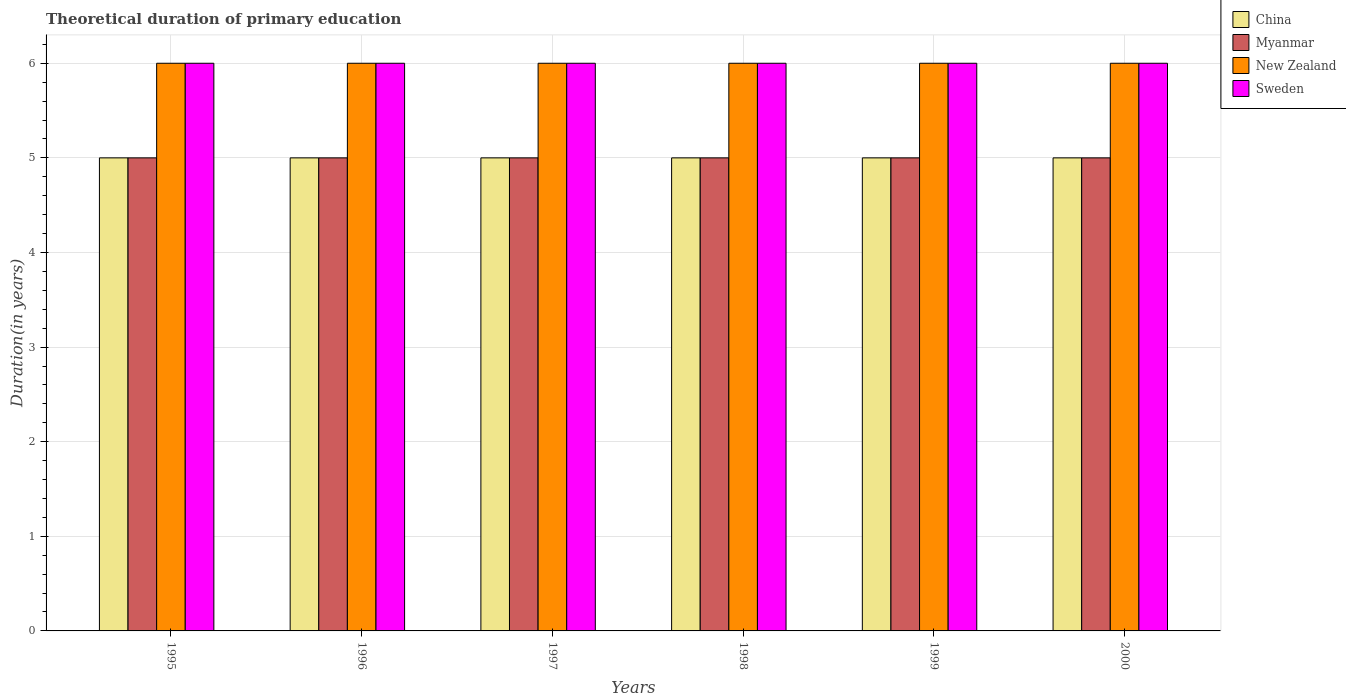How many groups of bars are there?
Ensure brevity in your answer.  6. How many bars are there on the 3rd tick from the left?
Your answer should be very brief. 4. What is the label of the 2nd group of bars from the left?
Your answer should be compact. 1996. What is the total theoretical duration of primary education in New Zealand in 2000?
Provide a short and direct response. 6. Across all years, what is the maximum total theoretical duration of primary education in China?
Provide a succinct answer. 5. Across all years, what is the minimum total theoretical duration of primary education in China?
Give a very brief answer. 5. What is the total total theoretical duration of primary education in China in the graph?
Your response must be concise. 30. What is the difference between the total theoretical duration of primary education in Sweden in 1998 and the total theoretical duration of primary education in China in 1996?
Ensure brevity in your answer.  1. Is the difference between the total theoretical duration of primary education in China in 1997 and 1998 greater than the difference between the total theoretical duration of primary education in Myanmar in 1997 and 1998?
Ensure brevity in your answer.  No. Is the sum of the total theoretical duration of primary education in China in 1995 and 2000 greater than the maximum total theoretical duration of primary education in New Zealand across all years?
Give a very brief answer. Yes. What does the 1st bar from the left in 1998 represents?
Keep it short and to the point. China. What does the 2nd bar from the right in 1999 represents?
Ensure brevity in your answer.  New Zealand. Is it the case that in every year, the sum of the total theoretical duration of primary education in Myanmar and total theoretical duration of primary education in Sweden is greater than the total theoretical duration of primary education in New Zealand?
Ensure brevity in your answer.  Yes. Are all the bars in the graph horizontal?
Make the answer very short. No. Does the graph contain any zero values?
Ensure brevity in your answer.  No. Where does the legend appear in the graph?
Provide a succinct answer. Top right. How are the legend labels stacked?
Your response must be concise. Vertical. What is the title of the graph?
Offer a terse response. Theoretical duration of primary education. What is the label or title of the X-axis?
Offer a very short reply. Years. What is the label or title of the Y-axis?
Make the answer very short. Duration(in years). What is the Duration(in years) in Myanmar in 1995?
Your answer should be very brief. 5. What is the Duration(in years) of New Zealand in 1995?
Provide a succinct answer. 6. What is the Duration(in years) of Sweden in 1995?
Provide a short and direct response. 6. What is the Duration(in years) of Myanmar in 1996?
Keep it short and to the point. 5. What is the Duration(in years) in New Zealand in 1996?
Make the answer very short. 6. What is the Duration(in years) in Sweden in 1996?
Ensure brevity in your answer.  6. What is the Duration(in years) in China in 1997?
Offer a very short reply. 5. What is the Duration(in years) of Myanmar in 1997?
Offer a very short reply. 5. What is the Duration(in years) in Sweden in 1997?
Your answer should be compact. 6. What is the Duration(in years) of China in 1998?
Your answer should be compact. 5. What is the Duration(in years) of New Zealand in 1998?
Your response must be concise. 6. What is the Duration(in years) of Sweden in 1998?
Ensure brevity in your answer.  6. What is the Duration(in years) of China in 1999?
Your answer should be compact. 5. What is the Duration(in years) of New Zealand in 1999?
Provide a succinct answer. 6. What is the Duration(in years) in China in 2000?
Offer a terse response. 5. What is the Duration(in years) of New Zealand in 2000?
Give a very brief answer. 6. What is the Duration(in years) of Sweden in 2000?
Give a very brief answer. 6. Across all years, what is the maximum Duration(in years) of China?
Ensure brevity in your answer.  5. Across all years, what is the maximum Duration(in years) in Myanmar?
Make the answer very short. 5. Across all years, what is the minimum Duration(in years) of China?
Offer a terse response. 5. Across all years, what is the minimum Duration(in years) of Myanmar?
Your answer should be compact. 5. Across all years, what is the minimum Duration(in years) in New Zealand?
Provide a short and direct response. 6. Across all years, what is the minimum Duration(in years) in Sweden?
Make the answer very short. 6. What is the total Duration(in years) in Myanmar in the graph?
Make the answer very short. 30. What is the total Duration(in years) of New Zealand in the graph?
Offer a terse response. 36. What is the difference between the Duration(in years) of China in 1995 and that in 1997?
Offer a terse response. 0. What is the difference between the Duration(in years) in Myanmar in 1995 and that in 1997?
Ensure brevity in your answer.  0. What is the difference between the Duration(in years) in New Zealand in 1995 and that in 1997?
Offer a terse response. 0. What is the difference between the Duration(in years) of Sweden in 1995 and that in 1997?
Give a very brief answer. 0. What is the difference between the Duration(in years) in Myanmar in 1995 and that in 1998?
Keep it short and to the point. 0. What is the difference between the Duration(in years) in New Zealand in 1995 and that in 1998?
Offer a terse response. 0. What is the difference between the Duration(in years) in New Zealand in 1995 and that in 1999?
Provide a short and direct response. 0. What is the difference between the Duration(in years) in China in 1995 and that in 2000?
Provide a succinct answer. 0. What is the difference between the Duration(in years) of Myanmar in 1996 and that in 1997?
Give a very brief answer. 0. What is the difference between the Duration(in years) of New Zealand in 1996 and that in 1997?
Provide a short and direct response. 0. What is the difference between the Duration(in years) of Myanmar in 1996 and that in 1998?
Provide a succinct answer. 0. What is the difference between the Duration(in years) of New Zealand in 1996 and that in 1998?
Ensure brevity in your answer.  0. What is the difference between the Duration(in years) of Myanmar in 1996 and that in 2000?
Your answer should be compact. 0. What is the difference between the Duration(in years) of New Zealand in 1996 and that in 2000?
Offer a very short reply. 0. What is the difference between the Duration(in years) in New Zealand in 1997 and that in 1998?
Give a very brief answer. 0. What is the difference between the Duration(in years) in New Zealand in 1997 and that in 1999?
Offer a terse response. 0. What is the difference between the Duration(in years) in Myanmar in 1997 and that in 2000?
Your answer should be very brief. 0. What is the difference between the Duration(in years) of New Zealand in 1997 and that in 2000?
Offer a terse response. 0. What is the difference between the Duration(in years) in Sweden in 1997 and that in 2000?
Offer a terse response. 0. What is the difference between the Duration(in years) in China in 1998 and that in 2000?
Provide a succinct answer. 0. What is the difference between the Duration(in years) in New Zealand in 1999 and that in 2000?
Ensure brevity in your answer.  0. What is the difference between the Duration(in years) of China in 1995 and the Duration(in years) of New Zealand in 1996?
Offer a very short reply. -1. What is the difference between the Duration(in years) of New Zealand in 1995 and the Duration(in years) of Sweden in 1996?
Your response must be concise. 0. What is the difference between the Duration(in years) in China in 1995 and the Duration(in years) in New Zealand in 1997?
Your answer should be compact. -1. What is the difference between the Duration(in years) in Myanmar in 1995 and the Duration(in years) in New Zealand in 1997?
Make the answer very short. -1. What is the difference between the Duration(in years) of Myanmar in 1995 and the Duration(in years) of Sweden in 1997?
Provide a succinct answer. -1. What is the difference between the Duration(in years) of New Zealand in 1995 and the Duration(in years) of Sweden in 1997?
Provide a succinct answer. 0. What is the difference between the Duration(in years) of China in 1995 and the Duration(in years) of Myanmar in 1998?
Offer a very short reply. 0. What is the difference between the Duration(in years) in China in 1995 and the Duration(in years) in New Zealand in 1998?
Keep it short and to the point. -1. What is the difference between the Duration(in years) of China in 1995 and the Duration(in years) of Sweden in 1998?
Offer a very short reply. -1. What is the difference between the Duration(in years) in Myanmar in 1995 and the Duration(in years) in Sweden in 1998?
Provide a succinct answer. -1. What is the difference between the Duration(in years) of Myanmar in 1995 and the Duration(in years) of New Zealand in 1999?
Keep it short and to the point. -1. What is the difference between the Duration(in years) of Myanmar in 1995 and the Duration(in years) of Sweden in 1999?
Your response must be concise. -1. What is the difference between the Duration(in years) in New Zealand in 1995 and the Duration(in years) in Sweden in 1999?
Make the answer very short. 0. What is the difference between the Duration(in years) of China in 1996 and the Duration(in years) of Myanmar in 1998?
Your response must be concise. 0. What is the difference between the Duration(in years) of China in 1996 and the Duration(in years) of New Zealand in 1998?
Offer a terse response. -1. What is the difference between the Duration(in years) in Myanmar in 1996 and the Duration(in years) in Sweden in 1998?
Provide a succinct answer. -1. What is the difference between the Duration(in years) in China in 1996 and the Duration(in years) in Myanmar in 1999?
Provide a short and direct response. 0. What is the difference between the Duration(in years) in China in 1996 and the Duration(in years) in New Zealand in 1999?
Your answer should be very brief. -1. What is the difference between the Duration(in years) in Myanmar in 1996 and the Duration(in years) in New Zealand in 1999?
Your answer should be very brief. -1. What is the difference between the Duration(in years) in Myanmar in 1996 and the Duration(in years) in Sweden in 1999?
Your answer should be very brief. -1. What is the difference between the Duration(in years) of New Zealand in 1996 and the Duration(in years) of Sweden in 1999?
Your answer should be compact. 0. What is the difference between the Duration(in years) in Myanmar in 1996 and the Duration(in years) in New Zealand in 2000?
Give a very brief answer. -1. What is the difference between the Duration(in years) of China in 1997 and the Duration(in years) of New Zealand in 1998?
Offer a terse response. -1. What is the difference between the Duration(in years) in New Zealand in 1997 and the Duration(in years) in Sweden in 1998?
Ensure brevity in your answer.  0. What is the difference between the Duration(in years) in China in 1997 and the Duration(in years) in New Zealand in 1999?
Give a very brief answer. -1. What is the difference between the Duration(in years) in China in 1997 and the Duration(in years) in Sweden in 1999?
Ensure brevity in your answer.  -1. What is the difference between the Duration(in years) in Myanmar in 1997 and the Duration(in years) in New Zealand in 1999?
Keep it short and to the point. -1. What is the difference between the Duration(in years) in Myanmar in 1997 and the Duration(in years) in Sweden in 1999?
Make the answer very short. -1. What is the difference between the Duration(in years) in Myanmar in 1997 and the Duration(in years) in New Zealand in 2000?
Ensure brevity in your answer.  -1. What is the difference between the Duration(in years) of Myanmar in 1997 and the Duration(in years) of Sweden in 2000?
Provide a short and direct response. -1. What is the difference between the Duration(in years) of China in 1998 and the Duration(in years) of New Zealand in 1999?
Provide a short and direct response. -1. What is the difference between the Duration(in years) in China in 1998 and the Duration(in years) in Sweden in 1999?
Your answer should be very brief. -1. What is the difference between the Duration(in years) of Myanmar in 1998 and the Duration(in years) of Sweden in 1999?
Make the answer very short. -1. What is the difference between the Duration(in years) in New Zealand in 1998 and the Duration(in years) in Sweden in 1999?
Provide a short and direct response. 0. What is the difference between the Duration(in years) in China in 1998 and the Duration(in years) in New Zealand in 2000?
Ensure brevity in your answer.  -1. What is the difference between the Duration(in years) of China in 1998 and the Duration(in years) of Sweden in 2000?
Make the answer very short. -1. What is the difference between the Duration(in years) of Myanmar in 1998 and the Duration(in years) of New Zealand in 2000?
Give a very brief answer. -1. What is the difference between the Duration(in years) in China in 1999 and the Duration(in years) in Myanmar in 2000?
Provide a succinct answer. 0. What is the difference between the Duration(in years) of China in 1999 and the Duration(in years) of Sweden in 2000?
Your response must be concise. -1. What is the difference between the Duration(in years) of Myanmar in 1999 and the Duration(in years) of New Zealand in 2000?
Give a very brief answer. -1. What is the difference between the Duration(in years) in Myanmar in 1999 and the Duration(in years) in Sweden in 2000?
Ensure brevity in your answer.  -1. What is the average Duration(in years) of New Zealand per year?
Provide a succinct answer. 6. What is the average Duration(in years) in Sweden per year?
Your response must be concise. 6. In the year 1995, what is the difference between the Duration(in years) in China and Duration(in years) in New Zealand?
Provide a succinct answer. -1. In the year 1995, what is the difference between the Duration(in years) of China and Duration(in years) of Sweden?
Provide a succinct answer. -1. In the year 1995, what is the difference between the Duration(in years) in New Zealand and Duration(in years) in Sweden?
Your answer should be compact. 0. In the year 1996, what is the difference between the Duration(in years) of Myanmar and Duration(in years) of Sweden?
Provide a succinct answer. -1. In the year 1996, what is the difference between the Duration(in years) in New Zealand and Duration(in years) in Sweden?
Provide a short and direct response. 0. In the year 1997, what is the difference between the Duration(in years) in China and Duration(in years) in Myanmar?
Offer a very short reply. 0. In the year 1997, what is the difference between the Duration(in years) of New Zealand and Duration(in years) of Sweden?
Your answer should be very brief. 0. In the year 1998, what is the difference between the Duration(in years) in China and Duration(in years) in Myanmar?
Ensure brevity in your answer.  0. In the year 1998, what is the difference between the Duration(in years) in New Zealand and Duration(in years) in Sweden?
Offer a terse response. 0. In the year 1999, what is the difference between the Duration(in years) in China and Duration(in years) in New Zealand?
Give a very brief answer. -1. In the year 1999, what is the difference between the Duration(in years) in China and Duration(in years) in Sweden?
Keep it short and to the point. -1. In the year 1999, what is the difference between the Duration(in years) of Myanmar and Duration(in years) of New Zealand?
Provide a succinct answer. -1. In the year 2000, what is the difference between the Duration(in years) of China and Duration(in years) of Myanmar?
Make the answer very short. 0. In the year 2000, what is the difference between the Duration(in years) in China and Duration(in years) in Sweden?
Make the answer very short. -1. In the year 2000, what is the difference between the Duration(in years) of Myanmar and Duration(in years) of Sweden?
Provide a succinct answer. -1. In the year 2000, what is the difference between the Duration(in years) in New Zealand and Duration(in years) in Sweden?
Ensure brevity in your answer.  0. What is the ratio of the Duration(in years) in Sweden in 1995 to that in 1996?
Provide a succinct answer. 1. What is the ratio of the Duration(in years) in Myanmar in 1995 to that in 1997?
Your answer should be very brief. 1. What is the ratio of the Duration(in years) in New Zealand in 1995 to that in 1997?
Make the answer very short. 1. What is the ratio of the Duration(in years) in Sweden in 1995 to that in 1997?
Ensure brevity in your answer.  1. What is the ratio of the Duration(in years) of China in 1995 to that in 1998?
Provide a short and direct response. 1. What is the ratio of the Duration(in years) of Myanmar in 1995 to that in 1998?
Make the answer very short. 1. What is the ratio of the Duration(in years) in New Zealand in 1995 to that in 1998?
Provide a short and direct response. 1. What is the ratio of the Duration(in years) of Sweden in 1995 to that in 1998?
Offer a terse response. 1. What is the ratio of the Duration(in years) in China in 1995 to that in 1999?
Your answer should be compact. 1. What is the ratio of the Duration(in years) of New Zealand in 1995 to that in 1999?
Provide a succinct answer. 1. What is the ratio of the Duration(in years) in Sweden in 1995 to that in 1999?
Ensure brevity in your answer.  1. What is the ratio of the Duration(in years) in China in 1996 to that in 1997?
Offer a terse response. 1. What is the ratio of the Duration(in years) of Sweden in 1996 to that in 1997?
Give a very brief answer. 1. What is the ratio of the Duration(in years) of China in 1996 to that in 1998?
Offer a terse response. 1. What is the ratio of the Duration(in years) of Myanmar in 1996 to that in 1998?
Offer a very short reply. 1. What is the ratio of the Duration(in years) in Sweden in 1996 to that in 1998?
Make the answer very short. 1. What is the ratio of the Duration(in years) in China in 1996 to that in 1999?
Keep it short and to the point. 1. What is the ratio of the Duration(in years) in China in 1996 to that in 2000?
Offer a very short reply. 1. What is the ratio of the Duration(in years) in New Zealand in 1996 to that in 2000?
Your answer should be very brief. 1. What is the ratio of the Duration(in years) in Myanmar in 1997 to that in 1998?
Your answer should be very brief. 1. What is the ratio of the Duration(in years) of New Zealand in 1997 to that in 1998?
Keep it short and to the point. 1. What is the ratio of the Duration(in years) of Sweden in 1997 to that in 1999?
Your answer should be compact. 1. What is the ratio of the Duration(in years) in China in 1997 to that in 2000?
Give a very brief answer. 1. What is the ratio of the Duration(in years) in New Zealand in 1997 to that in 2000?
Your answer should be compact. 1. What is the ratio of the Duration(in years) of China in 1998 to that in 2000?
Offer a terse response. 1. What is the ratio of the Duration(in years) in Myanmar in 1998 to that in 2000?
Ensure brevity in your answer.  1. What is the ratio of the Duration(in years) in China in 1999 to that in 2000?
Your answer should be compact. 1. What is the ratio of the Duration(in years) in Myanmar in 1999 to that in 2000?
Give a very brief answer. 1. What is the ratio of the Duration(in years) of Sweden in 1999 to that in 2000?
Provide a succinct answer. 1. What is the difference between the highest and the second highest Duration(in years) of China?
Your answer should be very brief. 0. What is the difference between the highest and the second highest Duration(in years) of Myanmar?
Your response must be concise. 0. What is the difference between the highest and the second highest Duration(in years) of Sweden?
Make the answer very short. 0. What is the difference between the highest and the lowest Duration(in years) of Sweden?
Your response must be concise. 0. 